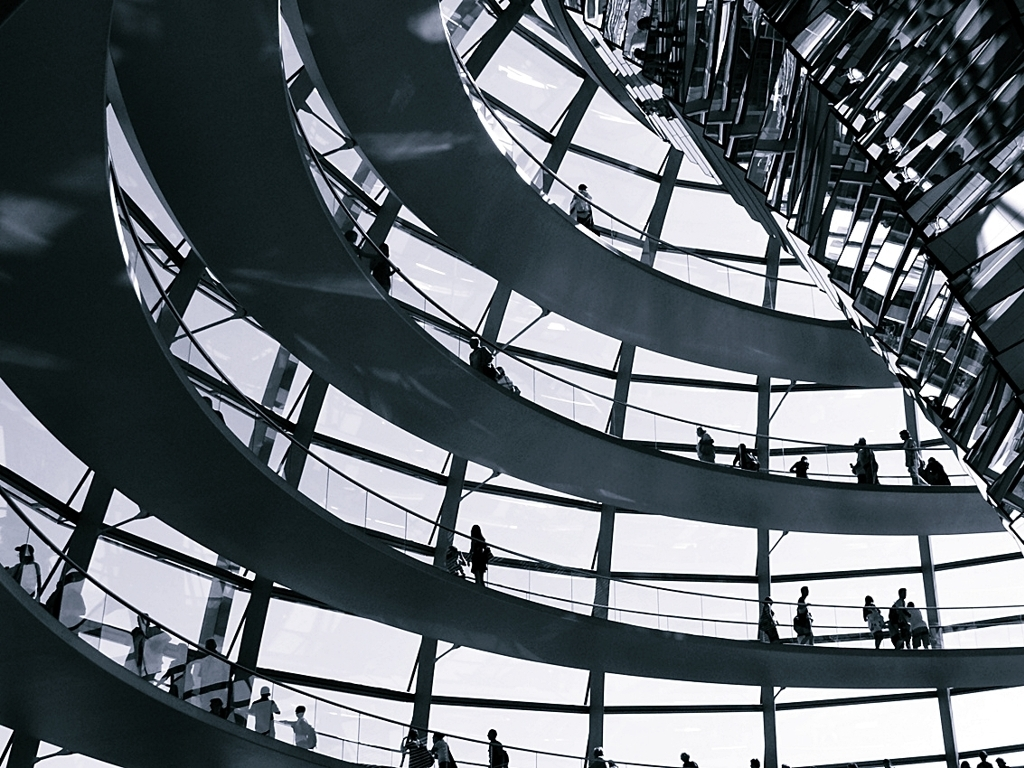Could you describe the mood or atmosphere of this place? The image conveys a contemporary and somewhat futuristic atmosphere, with its monochrome palette imparting a tranquil and sophisticated vibe. The ample light and open design suggest a place designed for reflection and public engagement. 